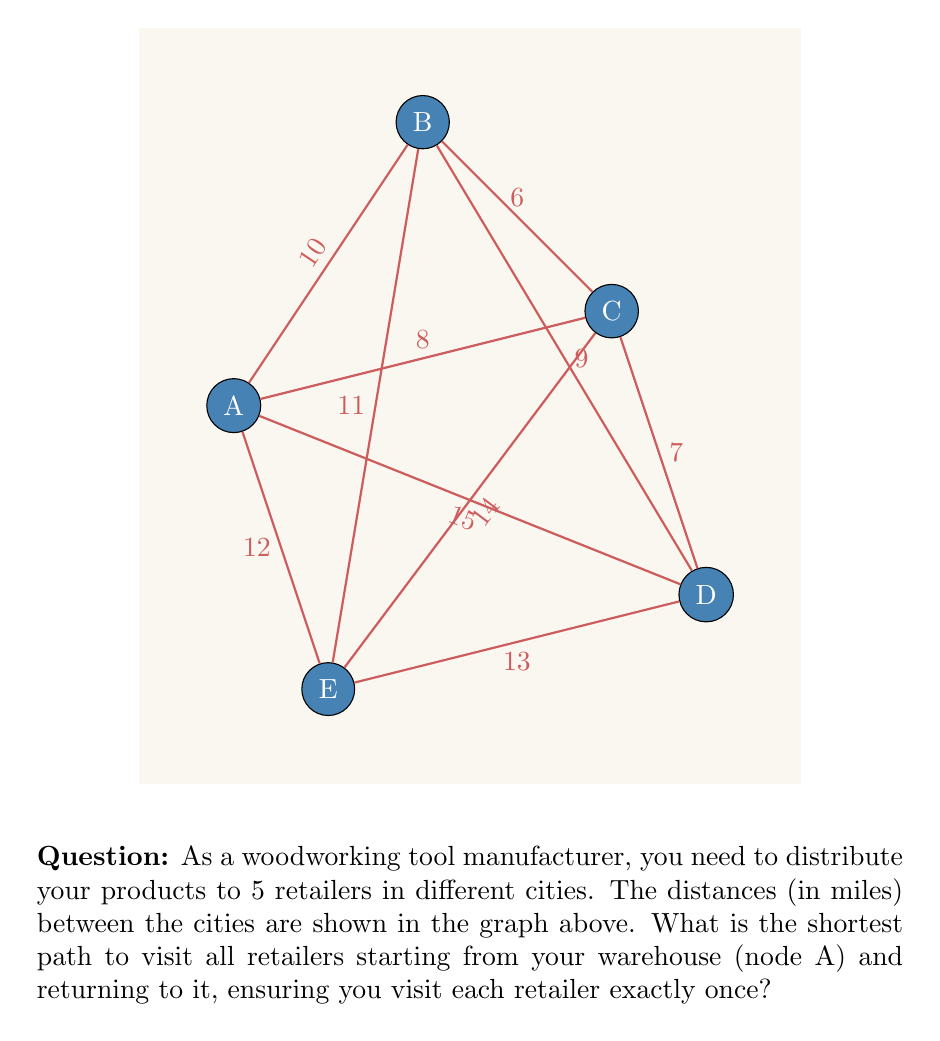What is the answer to this math problem? To solve this problem, we need to find the shortest Hamiltonian cycle in the given graph, which is known as the Traveling Salesman Problem (TSP). For a small graph like this, we can use the brute force approach to find the optimal solution.

Step 1: List all possible Hamiltonian cycles starting and ending at A.
There are $(5-1)! = 24$ possible cycles.

Step 2: Calculate the total distance for each cycle.
For example:
A-B-C-D-E-A: 10 + 6 + 7 + 13 + 12 = 48 miles
A-B-C-E-D-A: 10 + 6 + 14 + 13 + 15 = 58 miles
...

Step 3: Find the cycle with the minimum total distance.
After calculating all 24 cycles, we find that the shortest path is:
A-C-B-D-E-A with a total distance of 43 miles.

Step 4: Verify the distance of the shortest path:
A to C: 8 miles
C to B: 6 miles
B to D: 9 miles
D to E: 13 miles
E to A: 12 miles
Total: 8 + 6 + 9 + 13 + 12 = 43 miles

Therefore, the shortest path to visit all retailers starting from the warehouse (A) and returning to it is A-C-B-D-E-A, with a total distance of 43 miles.
Answer: A-C-B-D-E-A, 43 miles 